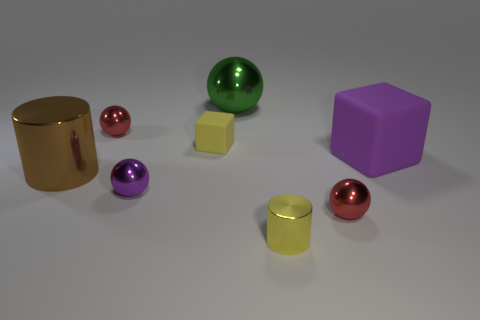Subtract all small spheres. How many spheres are left? 1 Subtract all purple spheres. How many spheres are left? 3 Add 1 brown rubber cylinders. How many objects exist? 9 Subtract all cyan balls. Subtract all yellow cylinders. How many balls are left? 4 Subtract all cylinders. How many objects are left? 6 Subtract 0 cyan cylinders. How many objects are left? 8 Subtract all yellow matte objects. Subtract all purple balls. How many objects are left? 6 Add 1 red metal objects. How many red metal objects are left? 3 Add 1 tiny blue cylinders. How many tiny blue cylinders exist? 1 